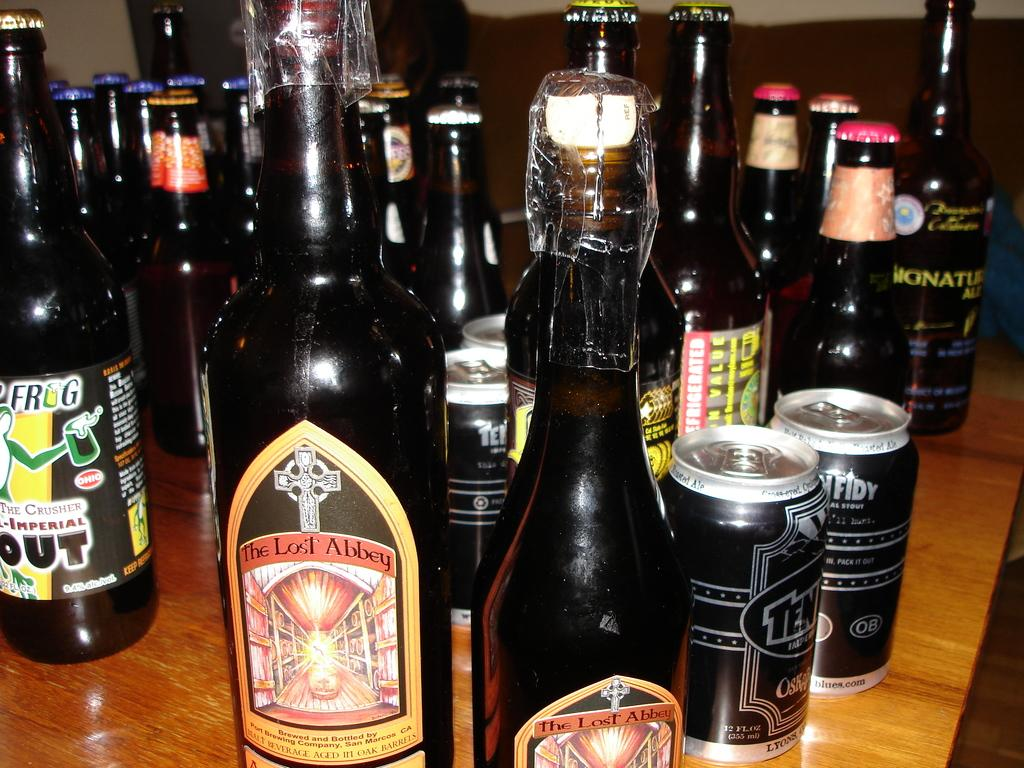<image>
Write a terse but informative summary of the picture. A bottle has a label with a cross and text of The Lost Abbey. 